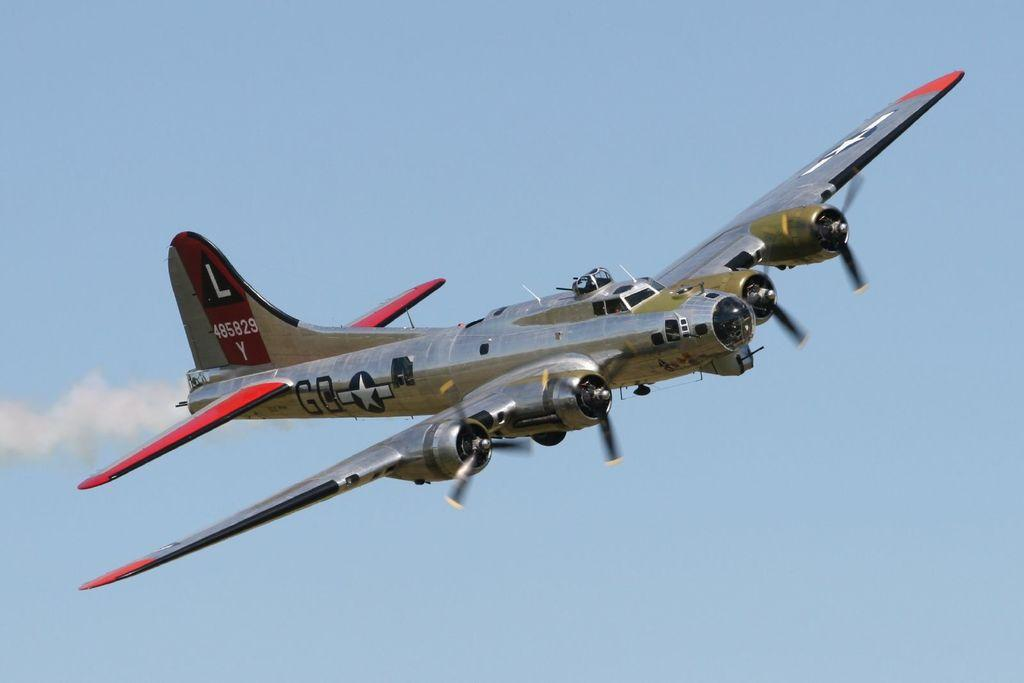Provide a one-sentence caption for the provided image. An old fashioned plane is flying through the sky with the sign "485829 Y" on the horizontal stabilizer. 